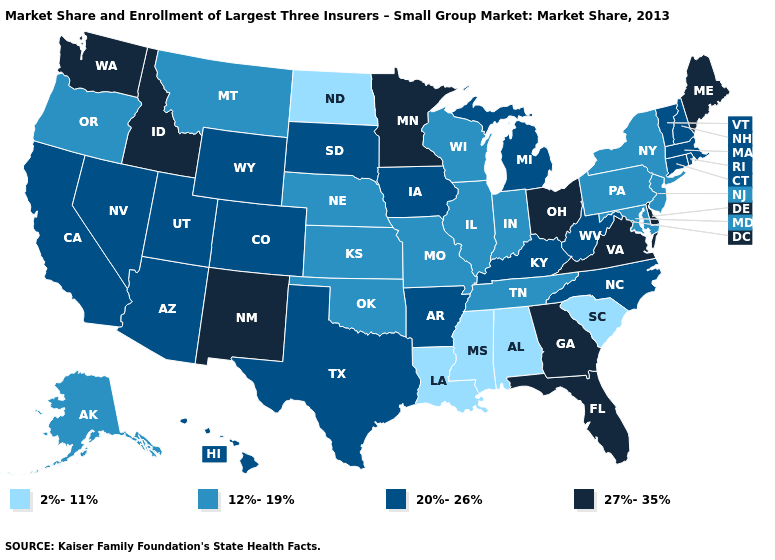Which states have the highest value in the USA?
Give a very brief answer. Delaware, Florida, Georgia, Idaho, Maine, Minnesota, New Mexico, Ohio, Virginia, Washington. Does New Mexico have the highest value in the West?
Write a very short answer. Yes. What is the lowest value in the MidWest?
Be succinct. 2%-11%. Does the map have missing data?
Keep it brief. No. Which states have the lowest value in the MidWest?
Short answer required. North Dakota. Which states have the highest value in the USA?
Write a very short answer. Delaware, Florida, Georgia, Idaho, Maine, Minnesota, New Mexico, Ohio, Virginia, Washington. Among the states that border Colorado , which have the lowest value?
Be succinct. Kansas, Nebraska, Oklahoma. Does Ohio have the lowest value in the USA?
Write a very short answer. No. Name the states that have a value in the range 12%-19%?
Short answer required. Alaska, Illinois, Indiana, Kansas, Maryland, Missouri, Montana, Nebraska, New Jersey, New York, Oklahoma, Oregon, Pennsylvania, Tennessee, Wisconsin. Name the states that have a value in the range 12%-19%?
Short answer required. Alaska, Illinois, Indiana, Kansas, Maryland, Missouri, Montana, Nebraska, New Jersey, New York, Oklahoma, Oregon, Pennsylvania, Tennessee, Wisconsin. What is the highest value in the USA?
Give a very brief answer. 27%-35%. Does Rhode Island have a lower value than Wisconsin?
Be succinct. No. How many symbols are there in the legend?
Concise answer only. 4. What is the value of Kentucky?
Concise answer only. 20%-26%. 